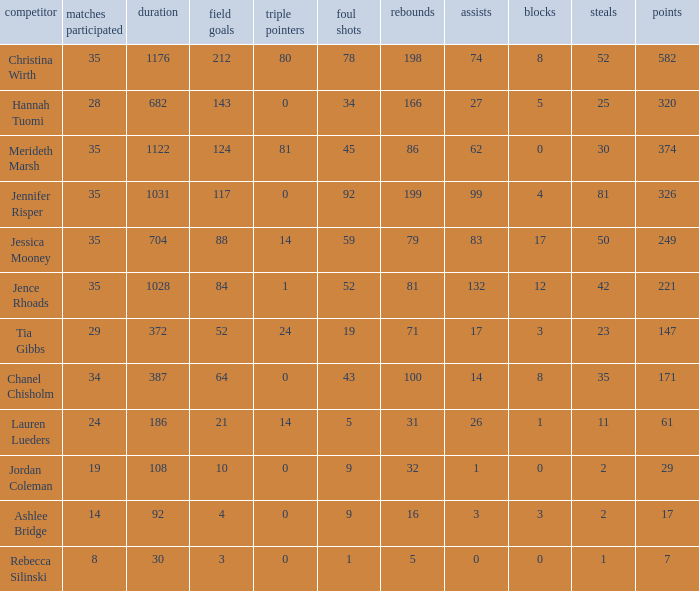What is the lowest number of 3 pointers that occured in games with 52 steals? 80.0. Parse the table in full. {'header': ['competitor', 'matches participated', 'duration', 'field goals', 'triple pointers', 'foul shots', 'rebounds', 'assists', 'blocks', 'steals', 'points'], 'rows': [['Christina Wirth', '35', '1176', '212', '80', '78', '198', '74', '8', '52', '582'], ['Hannah Tuomi', '28', '682', '143', '0', '34', '166', '27', '5', '25', '320'], ['Merideth Marsh', '35', '1122', '124', '81', '45', '86', '62', '0', '30', '374'], ['Jennifer Risper', '35', '1031', '117', '0', '92', '199', '99', '4', '81', '326'], ['Jessica Mooney', '35', '704', '88', '14', '59', '79', '83', '17', '50', '249'], ['Jence Rhoads', '35', '1028', '84', '1', '52', '81', '132', '12', '42', '221'], ['Tia Gibbs', '29', '372', '52', '24', '19', '71', '17', '3', '23', '147'], ['Chanel Chisholm', '34', '387', '64', '0', '43', '100', '14', '8', '35', '171'], ['Lauren Lueders', '24', '186', '21', '14', '5', '31', '26', '1', '11', '61'], ['Jordan Coleman', '19', '108', '10', '0', '9', '32', '1', '0', '2', '29'], ['Ashlee Bridge', '14', '92', '4', '0', '9', '16', '3', '3', '2', '17'], ['Rebecca Silinski', '8', '30', '3', '0', '1', '5', '0', '0', '1', '7']]} 